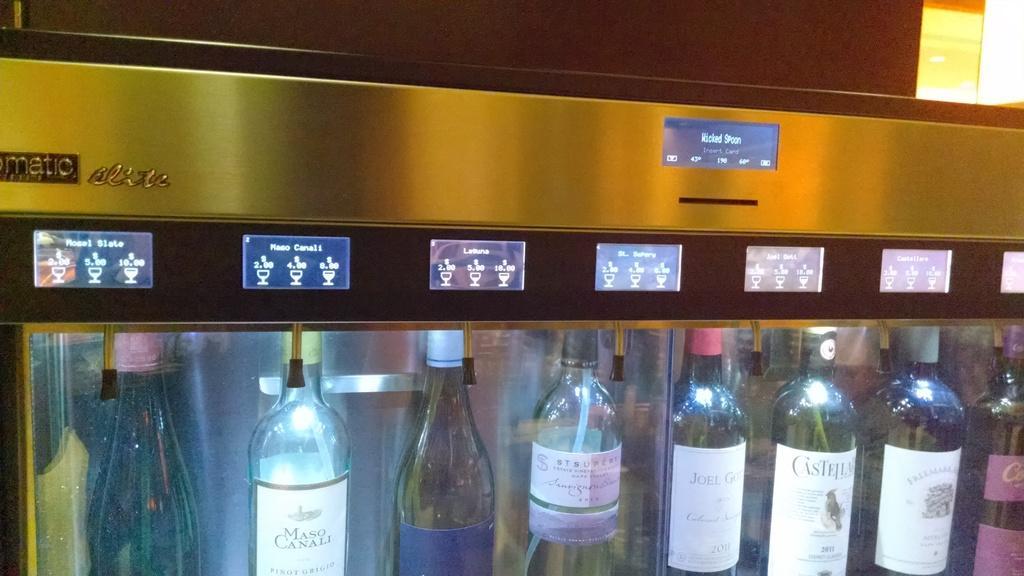How would you summarize this image in a sentence or two? There is a fridge with the glass door in which all the alcohol bottles are placed. 